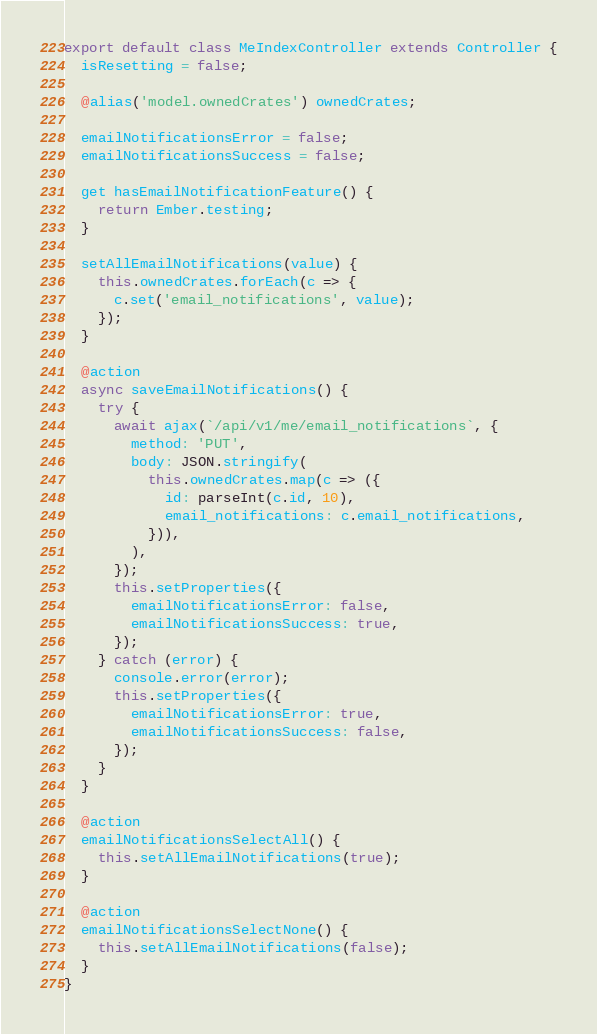Convert code to text. <code><loc_0><loc_0><loc_500><loc_500><_JavaScript_>export default class MeIndexController extends Controller {
  isResetting = false;

  @alias('model.ownedCrates') ownedCrates;

  emailNotificationsError = false;
  emailNotificationsSuccess = false;

  get hasEmailNotificationFeature() {
    return Ember.testing;
  }

  setAllEmailNotifications(value) {
    this.ownedCrates.forEach(c => {
      c.set('email_notifications', value);
    });
  }

  @action
  async saveEmailNotifications() {
    try {
      await ajax(`/api/v1/me/email_notifications`, {
        method: 'PUT',
        body: JSON.stringify(
          this.ownedCrates.map(c => ({
            id: parseInt(c.id, 10),
            email_notifications: c.email_notifications,
          })),
        ),
      });
      this.setProperties({
        emailNotificationsError: false,
        emailNotificationsSuccess: true,
      });
    } catch (error) {
      console.error(error);
      this.setProperties({
        emailNotificationsError: true,
        emailNotificationsSuccess: false,
      });
    }
  }

  @action
  emailNotificationsSelectAll() {
    this.setAllEmailNotifications(true);
  }

  @action
  emailNotificationsSelectNone() {
    this.setAllEmailNotifications(false);
  }
}
</code> 